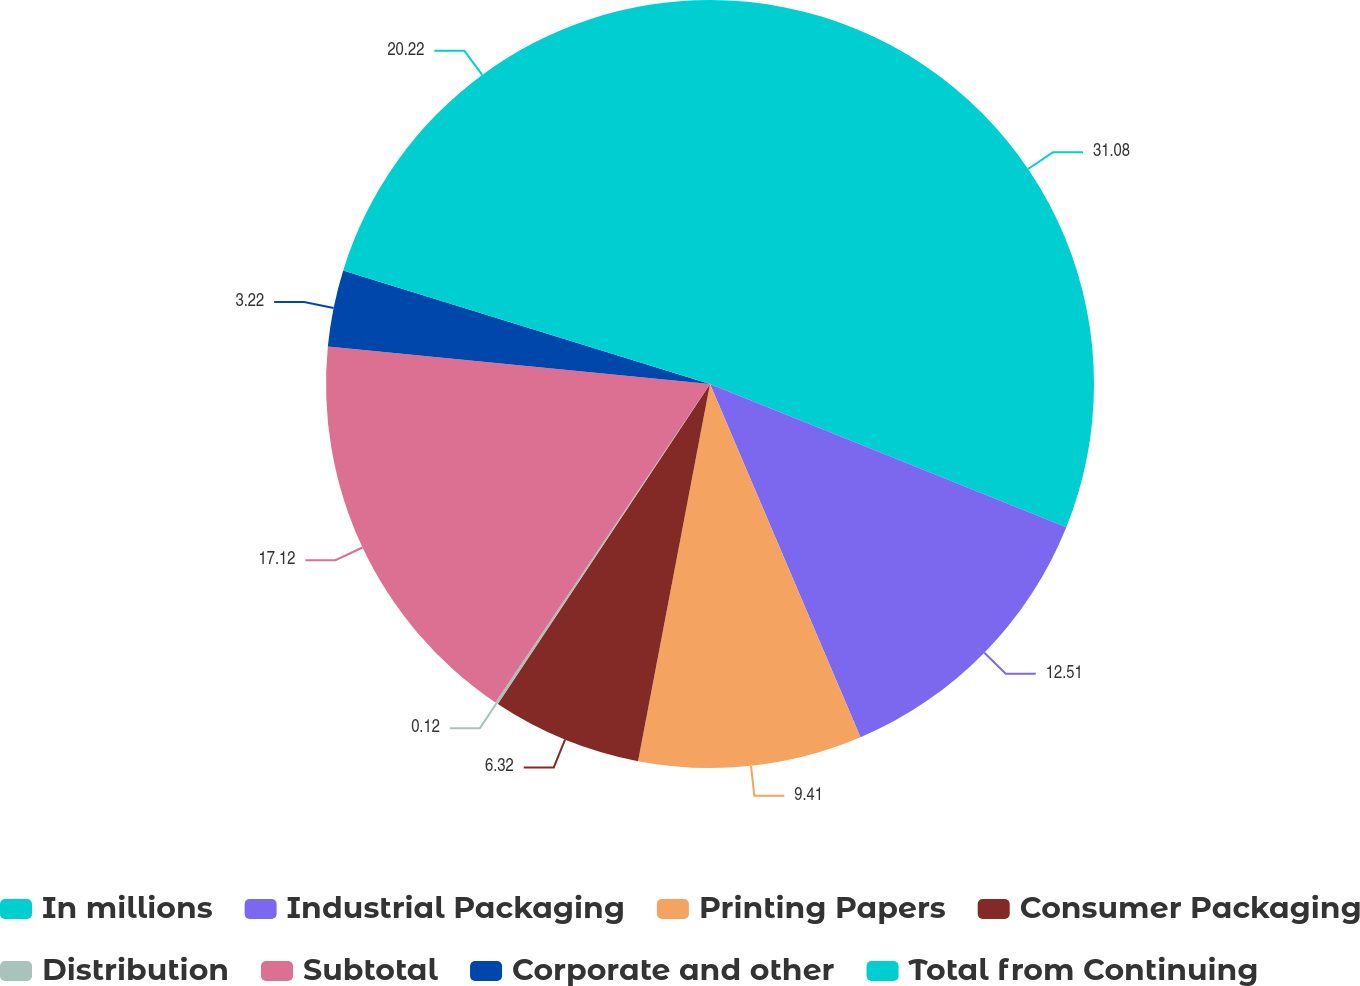Convert chart. <chart><loc_0><loc_0><loc_500><loc_500><pie_chart><fcel>In millions<fcel>Industrial Packaging<fcel>Printing Papers<fcel>Consumer Packaging<fcel>Distribution<fcel>Subtotal<fcel>Corporate and other<fcel>Total from Continuing<nl><fcel>31.08%<fcel>12.51%<fcel>9.41%<fcel>6.32%<fcel>0.12%<fcel>17.12%<fcel>3.22%<fcel>20.22%<nl></chart> 